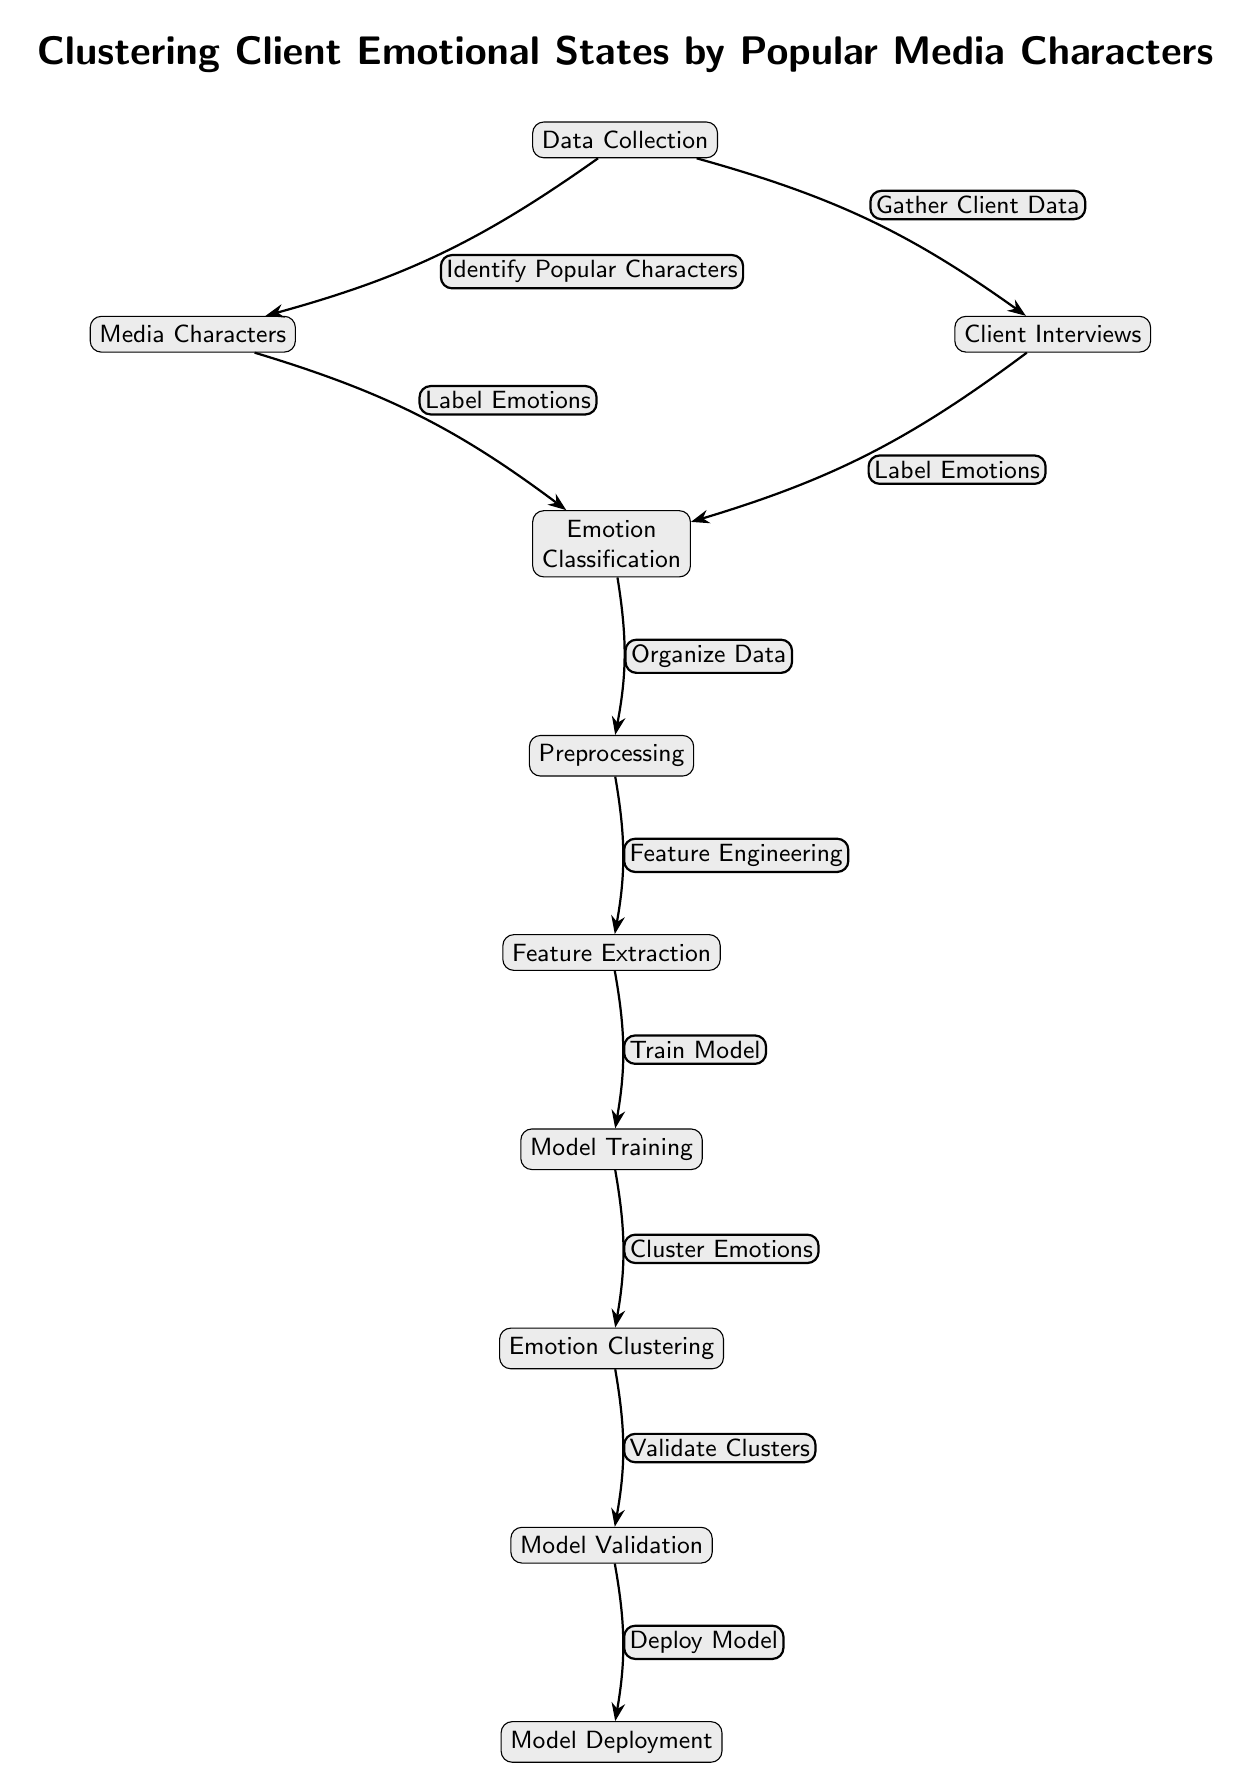What are the first two steps in the diagram? The first step in the diagram is "Data Collection," which leads to two subsequent steps: gathering data from "Media Characters" and "Client Interviews."
Answer: Data Collection, Media Characters, Client Interviews How many nodes are present in the diagram? By counting all the individual tasks and categories shown, there are 9 nodes present in the diagram.
Answer: 9 Which node follows "Emotion Classification"? According to the flow in the diagram, the node that comes next after "Emotion Classification" is "Preprocessing."
Answer: Preprocessing What is the purpose of the "Feature Extraction" node? The "Feature Extraction" node serves to process the organized data after preprocessing to extract relevant features for training the model.
Answer: Extract relevant features Which nodes contribute to "Emotion Classification" according to the diagram? The nodes contributing to "Emotion Classification" are "Media Characters" and "Client Interviews," as they both provide input labels for emotions.
Answer: Media Characters, Client Interviews What is the final step of the diagram called? The last step, which signifies the completion of the process outlined in the diagram, is called "Model Deployment."
Answer: Model Deployment What action occurs during the "Training" node? During the "Training" node, the model is trained on the specific features extracted to enable it to learn and subsequently cluster the emotions.
Answer: Train Model Which two nodes are directly connected to "Clustering"? The nodes that connect directly to "Clustering" are "Training" and "Validation," indicating the flow of processes leading to emotion clustering and its subsequent validation.
Answer: Training, Validation What is the flow before the "Model Validation" node? The flow of process before reaching the "Model Validation" node goes through "Clustering," meaning the clusters formed need to be validated before deployment.
Answer: Clustering 